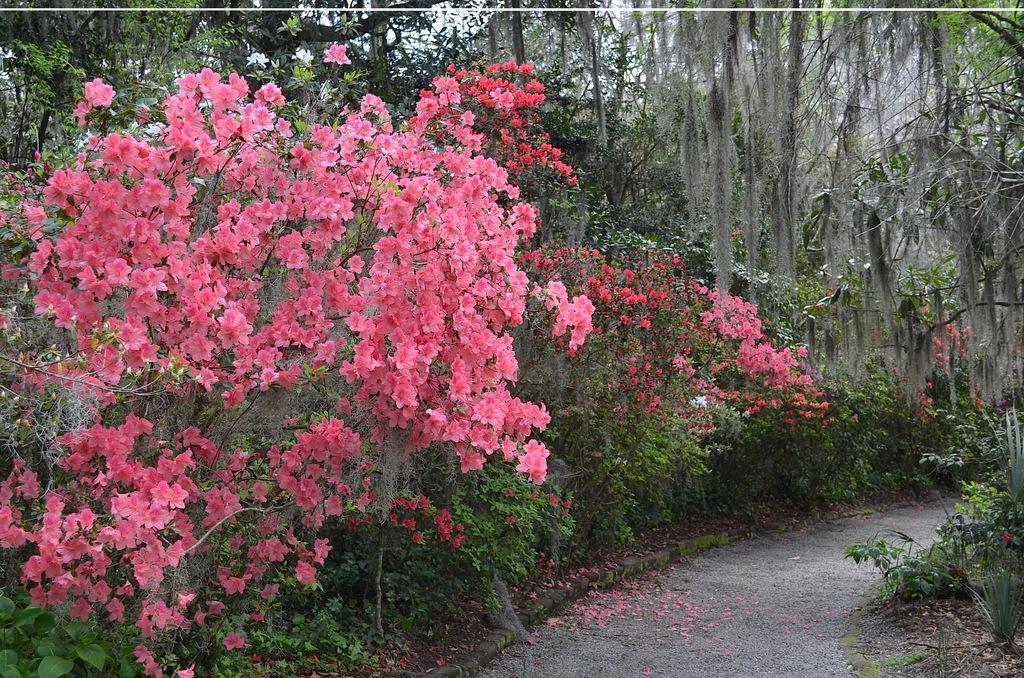Describe this image in one or two sentences. In this picture I can see few flowers, plants and trees, at the bottom it looks like the walkway. 